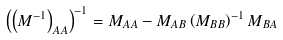<formula> <loc_0><loc_0><loc_500><loc_500>\left ( \left ( { M } ^ { - 1 } \right ) _ { A A } \right ) ^ { - 1 } = { M } _ { A A } - { M } _ { A B } \left ( { M } _ { B B } \right ) ^ { - 1 } { M } _ { B A }</formula> 